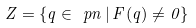Convert formula to latex. <formula><loc_0><loc_0><loc_500><loc_500>Z = \{ q \in \ p n \, | \, F ( q ) \neq 0 \}</formula> 